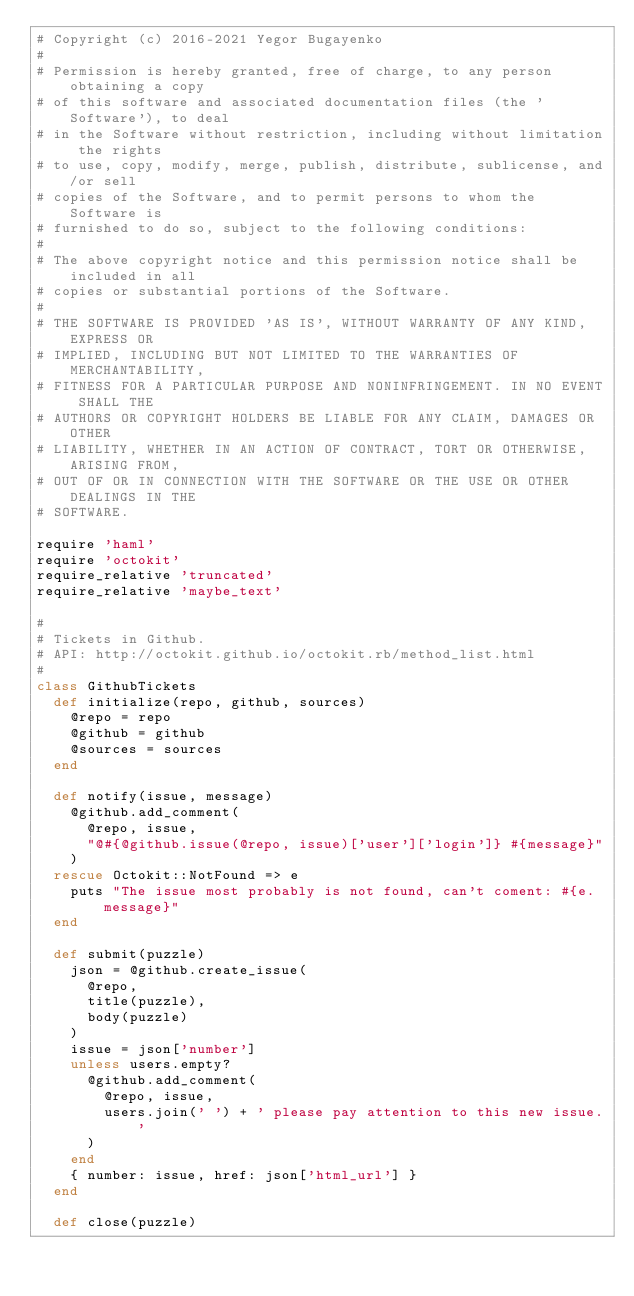<code> <loc_0><loc_0><loc_500><loc_500><_Ruby_># Copyright (c) 2016-2021 Yegor Bugayenko
#
# Permission is hereby granted, free of charge, to any person obtaining a copy
# of this software and associated documentation files (the 'Software'), to deal
# in the Software without restriction, including without limitation the rights
# to use, copy, modify, merge, publish, distribute, sublicense, and/or sell
# copies of the Software, and to permit persons to whom the Software is
# furnished to do so, subject to the following conditions:
#
# The above copyright notice and this permission notice shall be included in all
# copies or substantial portions of the Software.
#
# THE SOFTWARE IS PROVIDED 'AS IS', WITHOUT WARRANTY OF ANY KIND, EXPRESS OR
# IMPLIED, INCLUDING BUT NOT LIMITED TO THE WARRANTIES OF MERCHANTABILITY,
# FITNESS FOR A PARTICULAR PURPOSE AND NONINFRINGEMENT. IN NO EVENT SHALL THE
# AUTHORS OR COPYRIGHT HOLDERS BE LIABLE FOR ANY CLAIM, DAMAGES OR OTHER
# LIABILITY, WHETHER IN AN ACTION OF CONTRACT, TORT OR OTHERWISE, ARISING FROM,
# OUT OF OR IN CONNECTION WITH THE SOFTWARE OR THE USE OR OTHER DEALINGS IN THE
# SOFTWARE.

require 'haml'
require 'octokit'
require_relative 'truncated'
require_relative 'maybe_text'

#
# Tickets in Github.
# API: http://octokit.github.io/octokit.rb/method_list.html
#
class GithubTickets
  def initialize(repo, github, sources)
    @repo = repo
    @github = github
    @sources = sources
  end

  def notify(issue, message)
    @github.add_comment(
      @repo, issue,
      "@#{@github.issue(@repo, issue)['user']['login']} #{message}"
    )
  rescue Octokit::NotFound => e
    puts "The issue most probably is not found, can't coment: #{e.message}"
  end

  def submit(puzzle)
    json = @github.create_issue(
      @repo,
      title(puzzle),
      body(puzzle)
    )
    issue = json['number']
    unless users.empty?
      @github.add_comment(
        @repo, issue,
        users.join(' ') + ' please pay attention to this new issue.'
      )
    end
    { number: issue, href: json['html_url'] }
  end

  def close(puzzle)</code> 